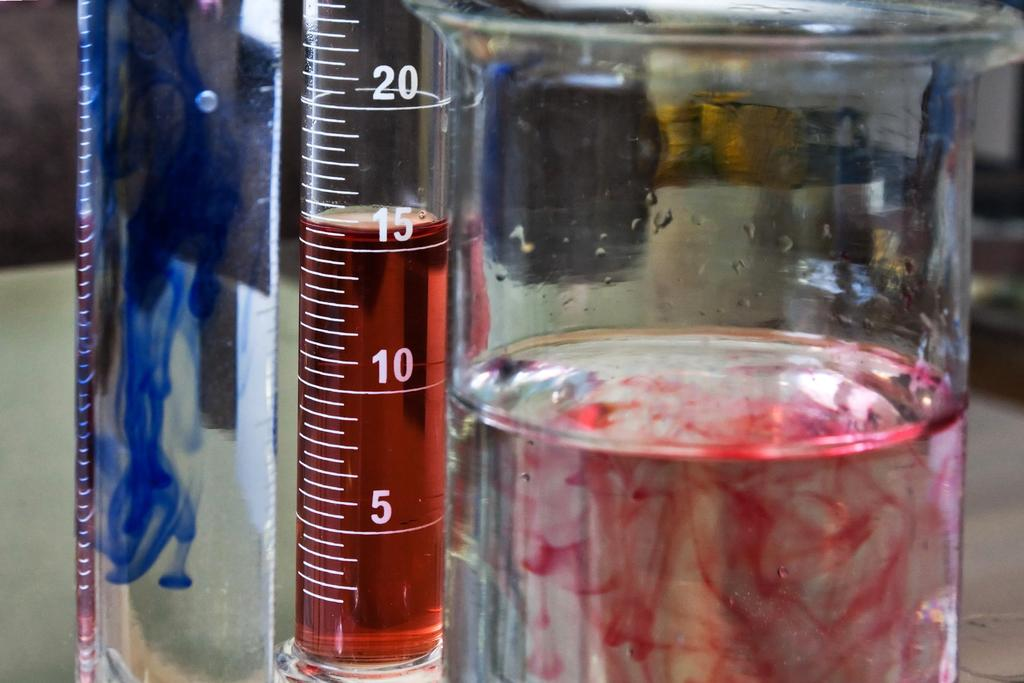<image>
Describe the image concisely. TWO TEST TUBES, ONE CONTAINS BLUE DYE AND THE OTHER RED, AND THE RED ONE IS AT 15ML 